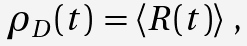Convert formula to latex. <formula><loc_0><loc_0><loc_500><loc_500>\begin{array} { c } \rho _ { D } ( t ) \, = \left \langle R ( t ) \right \rangle \, , \, \end{array}</formula> 